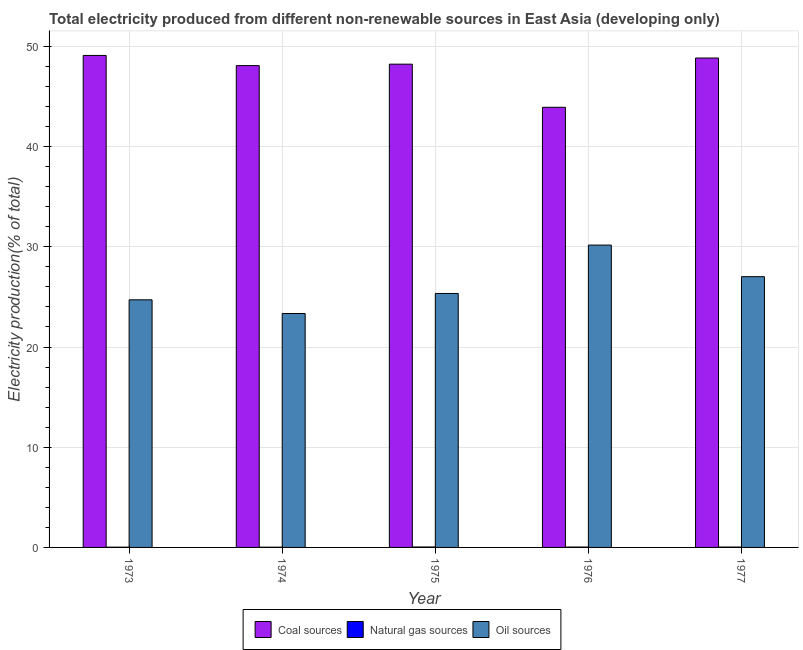How many groups of bars are there?
Your response must be concise. 5. Are the number of bars per tick equal to the number of legend labels?
Give a very brief answer. Yes. Are the number of bars on each tick of the X-axis equal?
Your response must be concise. Yes. How many bars are there on the 3rd tick from the right?
Ensure brevity in your answer.  3. What is the label of the 5th group of bars from the left?
Your answer should be very brief. 1977. What is the percentage of electricity produced by natural gas in 1974?
Provide a succinct answer. 0.02. Across all years, what is the maximum percentage of electricity produced by oil sources?
Your response must be concise. 30.17. Across all years, what is the minimum percentage of electricity produced by oil sources?
Your response must be concise. 23.34. In which year was the percentage of electricity produced by coal maximum?
Your response must be concise. 1973. In which year was the percentage of electricity produced by natural gas minimum?
Ensure brevity in your answer.  1974. What is the total percentage of electricity produced by natural gas in the graph?
Your answer should be very brief. 0.17. What is the difference between the percentage of electricity produced by oil sources in 1974 and that in 1975?
Provide a short and direct response. -2. What is the difference between the percentage of electricity produced by oil sources in 1974 and the percentage of electricity produced by coal in 1976?
Your response must be concise. -6.83. What is the average percentage of electricity produced by oil sources per year?
Give a very brief answer. 26.12. What is the ratio of the percentage of electricity produced by natural gas in 1974 to that in 1976?
Offer a terse response. 0.63. Is the difference between the percentage of electricity produced by oil sources in 1973 and 1976 greater than the difference between the percentage of electricity produced by natural gas in 1973 and 1976?
Offer a very short reply. No. What is the difference between the highest and the second highest percentage of electricity produced by natural gas?
Offer a very short reply. 0. What is the difference between the highest and the lowest percentage of electricity produced by coal?
Offer a very short reply. 5.18. In how many years, is the percentage of electricity produced by coal greater than the average percentage of electricity produced by coal taken over all years?
Offer a terse response. 4. Is the sum of the percentage of electricity produced by coal in 1973 and 1976 greater than the maximum percentage of electricity produced by natural gas across all years?
Offer a very short reply. Yes. What does the 1st bar from the left in 1976 represents?
Your answer should be compact. Coal sources. What does the 3rd bar from the right in 1974 represents?
Provide a short and direct response. Coal sources. Is it the case that in every year, the sum of the percentage of electricity produced by coal and percentage of electricity produced by natural gas is greater than the percentage of electricity produced by oil sources?
Ensure brevity in your answer.  Yes. Are all the bars in the graph horizontal?
Provide a succinct answer. No. Are the values on the major ticks of Y-axis written in scientific E-notation?
Provide a short and direct response. No. Does the graph contain any zero values?
Your response must be concise. No. How many legend labels are there?
Your answer should be very brief. 3. How are the legend labels stacked?
Your answer should be very brief. Horizontal. What is the title of the graph?
Give a very brief answer. Total electricity produced from different non-renewable sources in East Asia (developing only). What is the label or title of the Y-axis?
Your response must be concise. Electricity production(% of total). What is the Electricity production(% of total) of Coal sources in 1973?
Offer a terse response. 49.1. What is the Electricity production(% of total) of Natural gas sources in 1973?
Make the answer very short. 0.03. What is the Electricity production(% of total) in Oil sources in 1973?
Provide a short and direct response. 24.71. What is the Electricity production(% of total) of Coal sources in 1974?
Provide a short and direct response. 48.08. What is the Electricity production(% of total) in Natural gas sources in 1974?
Your response must be concise. 0.02. What is the Electricity production(% of total) of Oil sources in 1974?
Ensure brevity in your answer.  23.34. What is the Electricity production(% of total) in Coal sources in 1975?
Your response must be concise. 48.23. What is the Electricity production(% of total) in Natural gas sources in 1975?
Offer a terse response. 0.04. What is the Electricity production(% of total) of Oil sources in 1975?
Keep it short and to the point. 25.34. What is the Electricity production(% of total) in Coal sources in 1976?
Your answer should be very brief. 43.92. What is the Electricity production(% of total) of Natural gas sources in 1976?
Give a very brief answer. 0.04. What is the Electricity production(% of total) of Oil sources in 1976?
Offer a very short reply. 30.17. What is the Electricity production(% of total) in Coal sources in 1977?
Offer a terse response. 48.84. What is the Electricity production(% of total) of Natural gas sources in 1977?
Ensure brevity in your answer.  0.04. What is the Electricity production(% of total) of Oil sources in 1977?
Offer a very short reply. 27.02. Across all years, what is the maximum Electricity production(% of total) in Coal sources?
Give a very brief answer. 49.1. Across all years, what is the maximum Electricity production(% of total) in Natural gas sources?
Your answer should be compact. 0.04. Across all years, what is the maximum Electricity production(% of total) in Oil sources?
Offer a very short reply. 30.17. Across all years, what is the minimum Electricity production(% of total) of Coal sources?
Your answer should be very brief. 43.92. Across all years, what is the minimum Electricity production(% of total) of Natural gas sources?
Your answer should be very brief. 0.02. Across all years, what is the minimum Electricity production(% of total) in Oil sources?
Keep it short and to the point. 23.34. What is the total Electricity production(% of total) in Coal sources in the graph?
Keep it short and to the point. 238.18. What is the total Electricity production(% of total) in Natural gas sources in the graph?
Provide a short and direct response. 0.17. What is the total Electricity production(% of total) of Oil sources in the graph?
Give a very brief answer. 130.59. What is the difference between the Electricity production(% of total) in Coal sources in 1973 and that in 1974?
Provide a succinct answer. 1.02. What is the difference between the Electricity production(% of total) of Natural gas sources in 1973 and that in 1974?
Offer a terse response. 0. What is the difference between the Electricity production(% of total) in Oil sources in 1973 and that in 1974?
Your response must be concise. 1.37. What is the difference between the Electricity production(% of total) in Coal sources in 1973 and that in 1975?
Offer a terse response. 0.87. What is the difference between the Electricity production(% of total) of Natural gas sources in 1973 and that in 1975?
Make the answer very short. -0.02. What is the difference between the Electricity production(% of total) of Oil sources in 1973 and that in 1975?
Offer a very short reply. -0.63. What is the difference between the Electricity production(% of total) in Coal sources in 1973 and that in 1976?
Offer a very short reply. 5.18. What is the difference between the Electricity production(% of total) of Natural gas sources in 1973 and that in 1976?
Make the answer very short. -0.01. What is the difference between the Electricity production(% of total) in Oil sources in 1973 and that in 1976?
Provide a short and direct response. -5.46. What is the difference between the Electricity production(% of total) in Coal sources in 1973 and that in 1977?
Offer a terse response. 0.26. What is the difference between the Electricity production(% of total) in Natural gas sources in 1973 and that in 1977?
Provide a short and direct response. -0.01. What is the difference between the Electricity production(% of total) in Oil sources in 1973 and that in 1977?
Offer a very short reply. -2.31. What is the difference between the Electricity production(% of total) in Coal sources in 1974 and that in 1975?
Offer a very short reply. -0.14. What is the difference between the Electricity production(% of total) of Natural gas sources in 1974 and that in 1975?
Offer a terse response. -0.02. What is the difference between the Electricity production(% of total) of Oil sources in 1974 and that in 1975?
Make the answer very short. -2. What is the difference between the Electricity production(% of total) of Coal sources in 1974 and that in 1976?
Your answer should be very brief. 4.16. What is the difference between the Electricity production(% of total) of Natural gas sources in 1974 and that in 1976?
Give a very brief answer. -0.01. What is the difference between the Electricity production(% of total) of Oil sources in 1974 and that in 1976?
Give a very brief answer. -6.83. What is the difference between the Electricity production(% of total) of Coal sources in 1974 and that in 1977?
Provide a succinct answer. -0.76. What is the difference between the Electricity production(% of total) in Natural gas sources in 1974 and that in 1977?
Your answer should be very brief. -0.02. What is the difference between the Electricity production(% of total) of Oil sources in 1974 and that in 1977?
Your response must be concise. -3.67. What is the difference between the Electricity production(% of total) of Coal sources in 1975 and that in 1976?
Your answer should be compact. 4.3. What is the difference between the Electricity production(% of total) in Natural gas sources in 1975 and that in 1976?
Ensure brevity in your answer.  0.01. What is the difference between the Electricity production(% of total) in Oil sources in 1975 and that in 1976?
Provide a short and direct response. -4.83. What is the difference between the Electricity production(% of total) of Coal sources in 1975 and that in 1977?
Provide a succinct answer. -0.61. What is the difference between the Electricity production(% of total) of Natural gas sources in 1975 and that in 1977?
Provide a succinct answer. 0. What is the difference between the Electricity production(% of total) of Oil sources in 1975 and that in 1977?
Offer a terse response. -1.67. What is the difference between the Electricity production(% of total) of Coal sources in 1976 and that in 1977?
Ensure brevity in your answer.  -4.92. What is the difference between the Electricity production(% of total) of Natural gas sources in 1976 and that in 1977?
Offer a very short reply. -0. What is the difference between the Electricity production(% of total) of Oil sources in 1976 and that in 1977?
Your response must be concise. 3.15. What is the difference between the Electricity production(% of total) in Coal sources in 1973 and the Electricity production(% of total) in Natural gas sources in 1974?
Keep it short and to the point. 49.08. What is the difference between the Electricity production(% of total) of Coal sources in 1973 and the Electricity production(% of total) of Oil sources in 1974?
Offer a terse response. 25.76. What is the difference between the Electricity production(% of total) in Natural gas sources in 1973 and the Electricity production(% of total) in Oil sources in 1974?
Your answer should be very brief. -23.32. What is the difference between the Electricity production(% of total) of Coal sources in 1973 and the Electricity production(% of total) of Natural gas sources in 1975?
Provide a succinct answer. 49.06. What is the difference between the Electricity production(% of total) of Coal sources in 1973 and the Electricity production(% of total) of Oil sources in 1975?
Your response must be concise. 23.76. What is the difference between the Electricity production(% of total) in Natural gas sources in 1973 and the Electricity production(% of total) in Oil sources in 1975?
Provide a short and direct response. -25.32. What is the difference between the Electricity production(% of total) in Coal sources in 1973 and the Electricity production(% of total) in Natural gas sources in 1976?
Your answer should be very brief. 49.06. What is the difference between the Electricity production(% of total) in Coal sources in 1973 and the Electricity production(% of total) in Oil sources in 1976?
Provide a short and direct response. 18.93. What is the difference between the Electricity production(% of total) of Natural gas sources in 1973 and the Electricity production(% of total) of Oil sources in 1976?
Offer a terse response. -30.15. What is the difference between the Electricity production(% of total) of Coal sources in 1973 and the Electricity production(% of total) of Natural gas sources in 1977?
Keep it short and to the point. 49.06. What is the difference between the Electricity production(% of total) in Coal sources in 1973 and the Electricity production(% of total) in Oil sources in 1977?
Offer a terse response. 22.08. What is the difference between the Electricity production(% of total) in Natural gas sources in 1973 and the Electricity production(% of total) in Oil sources in 1977?
Offer a terse response. -26.99. What is the difference between the Electricity production(% of total) in Coal sources in 1974 and the Electricity production(% of total) in Natural gas sources in 1975?
Your answer should be very brief. 48.04. What is the difference between the Electricity production(% of total) in Coal sources in 1974 and the Electricity production(% of total) in Oil sources in 1975?
Your answer should be very brief. 22.74. What is the difference between the Electricity production(% of total) of Natural gas sources in 1974 and the Electricity production(% of total) of Oil sources in 1975?
Your answer should be very brief. -25.32. What is the difference between the Electricity production(% of total) in Coal sources in 1974 and the Electricity production(% of total) in Natural gas sources in 1976?
Your response must be concise. 48.05. What is the difference between the Electricity production(% of total) in Coal sources in 1974 and the Electricity production(% of total) in Oil sources in 1976?
Provide a succinct answer. 17.91. What is the difference between the Electricity production(% of total) in Natural gas sources in 1974 and the Electricity production(% of total) in Oil sources in 1976?
Your answer should be compact. -30.15. What is the difference between the Electricity production(% of total) of Coal sources in 1974 and the Electricity production(% of total) of Natural gas sources in 1977?
Your answer should be very brief. 48.04. What is the difference between the Electricity production(% of total) in Coal sources in 1974 and the Electricity production(% of total) in Oil sources in 1977?
Keep it short and to the point. 21.06. What is the difference between the Electricity production(% of total) of Natural gas sources in 1974 and the Electricity production(% of total) of Oil sources in 1977?
Keep it short and to the point. -27. What is the difference between the Electricity production(% of total) of Coal sources in 1975 and the Electricity production(% of total) of Natural gas sources in 1976?
Make the answer very short. 48.19. What is the difference between the Electricity production(% of total) in Coal sources in 1975 and the Electricity production(% of total) in Oil sources in 1976?
Your answer should be very brief. 18.06. What is the difference between the Electricity production(% of total) of Natural gas sources in 1975 and the Electricity production(% of total) of Oil sources in 1976?
Your response must be concise. -30.13. What is the difference between the Electricity production(% of total) of Coal sources in 1975 and the Electricity production(% of total) of Natural gas sources in 1977?
Offer a terse response. 48.19. What is the difference between the Electricity production(% of total) of Coal sources in 1975 and the Electricity production(% of total) of Oil sources in 1977?
Your answer should be compact. 21.21. What is the difference between the Electricity production(% of total) in Natural gas sources in 1975 and the Electricity production(% of total) in Oil sources in 1977?
Ensure brevity in your answer.  -26.98. What is the difference between the Electricity production(% of total) in Coal sources in 1976 and the Electricity production(% of total) in Natural gas sources in 1977?
Give a very brief answer. 43.89. What is the difference between the Electricity production(% of total) of Coal sources in 1976 and the Electricity production(% of total) of Oil sources in 1977?
Your response must be concise. 16.9. What is the difference between the Electricity production(% of total) of Natural gas sources in 1976 and the Electricity production(% of total) of Oil sources in 1977?
Keep it short and to the point. -26.98. What is the average Electricity production(% of total) in Coal sources per year?
Provide a short and direct response. 47.64. What is the average Electricity production(% of total) in Oil sources per year?
Make the answer very short. 26.12. In the year 1973, what is the difference between the Electricity production(% of total) in Coal sources and Electricity production(% of total) in Natural gas sources?
Offer a very short reply. 49.08. In the year 1973, what is the difference between the Electricity production(% of total) of Coal sources and Electricity production(% of total) of Oil sources?
Your response must be concise. 24.39. In the year 1973, what is the difference between the Electricity production(% of total) in Natural gas sources and Electricity production(% of total) in Oil sources?
Give a very brief answer. -24.69. In the year 1974, what is the difference between the Electricity production(% of total) of Coal sources and Electricity production(% of total) of Natural gas sources?
Keep it short and to the point. 48.06. In the year 1974, what is the difference between the Electricity production(% of total) in Coal sources and Electricity production(% of total) in Oil sources?
Offer a very short reply. 24.74. In the year 1974, what is the difference between the Electricity production(% of total) in Natural gas sources and Electricity production(% of total) in Oil sources?
Give a very brief answer. -23.32. In the year 1975, what is the difference between the Electricity production(% of total) in Coal sources and Electricity production(% of total) in Natural gas sources?
Give a very brief answer. 48.18. In the year 1975, what is the difference between the Electricity production(% of total) of Coal sources and Electricity production(% of total) of Oil sources?
Give a very brief answer. 22.88. In the year 1975, what is the difference between the Electricity production(% of total) in Natural gas sources and Electricity production(% of total) in Oil sources?
Your response must be concise. -25.3. In the year 1976, what is the difference between the Electricity production(% of total) in Coal sources and Electricity production(% of total) in Natural gas sources?
Offer a very short reply. 43.89. In the year 1976, what is the difference between the Electricity production(% of total) in Coal sources and Electricity production(% of total) in Oil sources?
Provide a short and direct response. 13.75. In the year 1976, what is the difference between the Electricity production(% of total) of Natural gas sources and Electricity production(% of total) of Oil sources?
Provide a succinct answer. -30.14. In the year 1977, what is the difference between the Electricity production(% of total) of Coal sources and Electricity production(% of total) of Natural gas sources?
Offer a terse response. 48.8. In the year 1977, what is the difference between the Electricity production(% of total) in Coal sources and Electricity production(% of total) in Oil sources?
Provide a succinct answer. 21.82. In the year 1977, what is the difference between the Electricity production(% of total) in Natural gas sources and Electricity production(% of total) in Oil sources?
Your answer should be compact. -26.98. What is the ratio of the Electricity production(% of total) in Coal sources in 1973 to that in 1974?
Your answer should be very brief. 1.02. What is the ratio of the Electricity production(% of total) of Natural gas sources in 1973 to that in 1974?
Offer a very short reply. 1.08. What is the ratio of the Electricity production(% of total) of Oil sources in 1973 to that in 1974?
Keep it short and to the point. 1.06. What is the ratio of the Electricity production(% of total) in Coal sources in 1973 to that in 1975?
Make the answer very short. 1.02. What is the ratio of the Electricity production(% of total) of Natural gas sources in 1973 to that in 1975?
Your answer should be very brief. 0.58. What is the ratio of the Electricity production(% of total) of Coal sources in 1973 to that in 1976?
Your answer should be compact. 1.12. What is the ratio of the Electricity production(% of total) in Natural gas sources in 1973 to that in 1976?
Offer a terse response. 0.68. What is the ratio of the Electricity production(% of total) in Oil sources in 1973 to that in 1976?
Your answer should be compact. 0.82. What is the ratio of the Electricity production(% of total) in Coal sources in 1973 to that in 1977?
Provide a succinct answer. 1.01. What is the ratio of the Electricity production(% of total) in Natural gas sources in 1973 to that in 1977?
Your answer should be very brief. 0.65. What is the ratio of the Electricity production(% of total) of Oil sources in 1973 to that in 1977?
Provide a succinct answer. 0.91. What is the ratio of the Electricity production(% of total) in Coal sources in 1974 to that in 1975?
Offer a very short reply. 1. What is the ratio of the Electricity production(% of total) in Natural gas sources in 1974 to that in 1975?
Give a very brief answer. 0.54. What is the ratio of the Electricity production(% of total) in Oil sources in 1974 to that in 1975?
Give a very brief answer. 0.92. What is the ratio of the Electricity production(% of total) in Coal sources in 1974 to that in 1976?
Your response must be concise. 1.09. What is the ratio of the Electricity production(% of total) in Natural gas sources in 1974 to that in 1976?
Your answer should be very brief. 0.63. What is the ratio of the Electricity production(% of total) in Oil sources in 1974 to that in 1976?
Offer a terse response. 0.77. What is the ratio of the Electricity production(% of total) of Coal sources in 1974 to that in 1977?
Offer a very short reply. 0.98. What is the ratio of the Electricity production(% of total) of Natural gas sources in 1974 to that in 1977?
Your answer should be compact. 0.61. What is the ratio of the Electricity production(% of total) of Oil sources in 1974 to that in 1977?
Provide a short and direct response. 0.86. What is the ratio of the Electricity production(% of total) of Coal sources in 1975 to that in 1976?
Keep it short and to the point. 1.1. What is the ratio of the Electricity production(% of total) in Natural gas sources in 1975 to that in 1976?
Provide a succinct answer. 1.16. What is the ratio of the Electricity production(% of total) in Oil sources in 1975 to that in 1976?
Offer a very short reply. 0.84. What is the ratio of the Electricity production(% of total) of Coal sources in 1975 to that in 1977?
Keep it short and to the point. 0.99. What is the ratio of the Electricity production(% of total) of Natural gas sources in 1975 to that in 1977?
Provide a succinct answer. 1.12. What is the ratio of the Electricity production(% of total) in Oil sources in 1975 to that in 1977?
Offer a terse response. 0.94. What is the ratio of the Electricity production(% of total) of Coal sources in 1976 to that in 1977?
Your answer should be very brief. 0.9. What is the ratio of the Electricity production(% of total) of Oil sources in 1976 to that in 1977?
Ensure brevity in your answer.  1.12. What is the difference between the highest and the second highest Electricity production(% of total) of Coal sources?
Offer a terse response. 0.26. What is the difference between the highest and the second highest Electricity production(% of total) of Natural gas sources?
Your response must be concise. 0. What is the difference between the highest and the second highest Electricity production(% of total) of Oil sources?
Ensure brevity in your answer.  3.15. What is the difference between the highest and the lowest Electricity production(% of total) in Coal sources?
Offer a terse response. 5.18. What is the difference between the highest and the lowest Electricity production(% of total) of Natural gas sources?
Make the answer very short. 0.02. What is the difference between the highest and the lowest Electricity production(% of total) of Oil sources?
Offer a terse response. 6.83. 